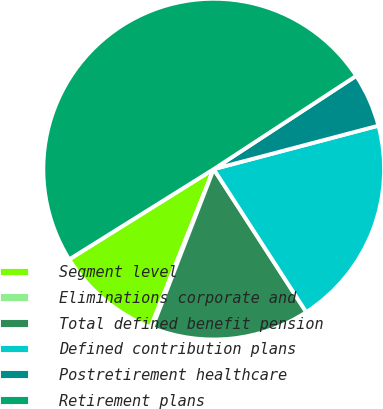Convert chart to OTSL. <chart><loc_0><loc_0><loc_500><loc_500><pie_chart><fcel>Segment level<fcel>Eliminations corporate and<fcel>Total defined benefit pension<fcel>Defined contribution plans<fcel>Postretirement healthcare<fcel>Retirement plans<nl><fcel>10.07%<fcel>0.17%<fcel>15.02%<fcel>19.97%<fcel>5.12%<fcel>49.67%<nl></chart> 